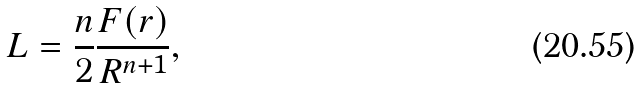<formula> <loc_0><loc_0><loc_500><loc_500>L = \frac { n } { 2 } \frac { F ( r ) } { R ^ { n + 1 } } ,</formula> 